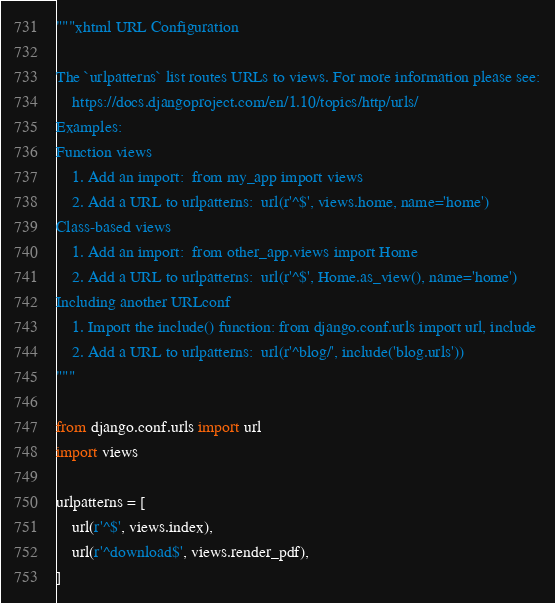<code> <loc_0><loc_0><loc_500><loc_500><_Python_>"""xhtml URL Configuration

The `urlpatterns` list routes URLs to views. For more information please see:
    https://docs.djangoproject.com/en/1.10/topics/http/urls/
Examples:
Function views
    1. Add an import:  from my_app import views
    2. Add a URL to urlpatterns:  url(r'^$', views.home, name='home')
Class-based views
    1. Add an import:  from other_app.views import Home
    2. Add a URL to urlpatterns:  url(r'^$', Home.as_view(), name='home')
Including another URLconf
    1. Import the include() function: from django.conf.urls import url, include
    2. Add a URL to urlpatterns:  url(r'^blog/', include('blog.urls'))
"""

from django.conf.urls import url
import views

urlpatterns = [
    url(r'^$', views.index),
    url(r'^download$', views.render_pdf),
]
</code> 